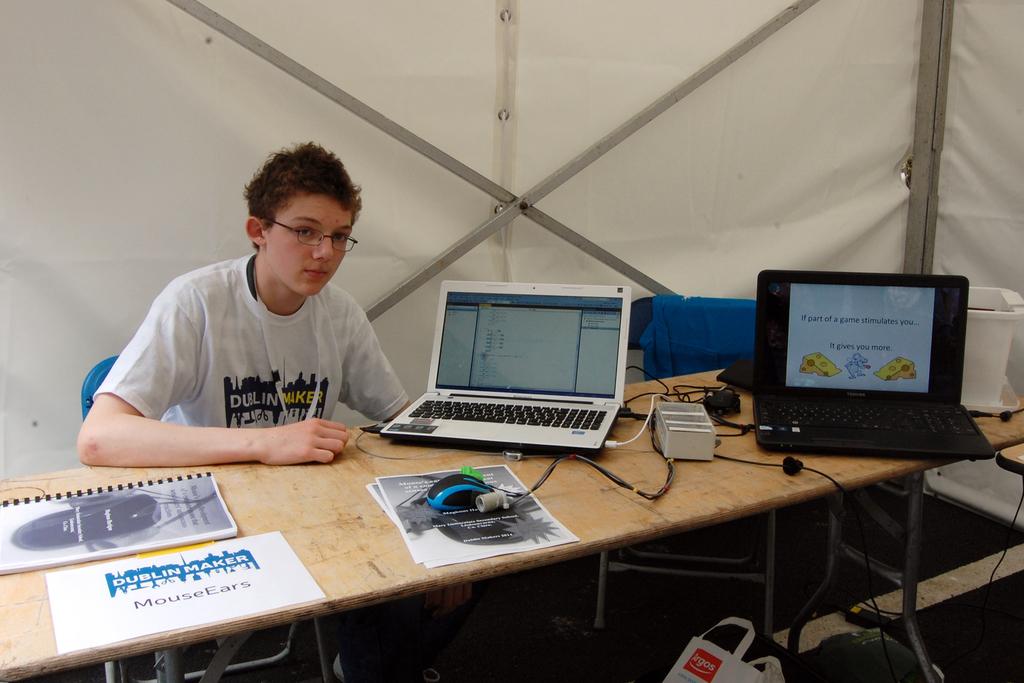What does the shirt say?
Offer a very short reply. Dublin maker. What kind of ears are on the paper on the left front of the table?
Your answer should be very brief. Mouse. 